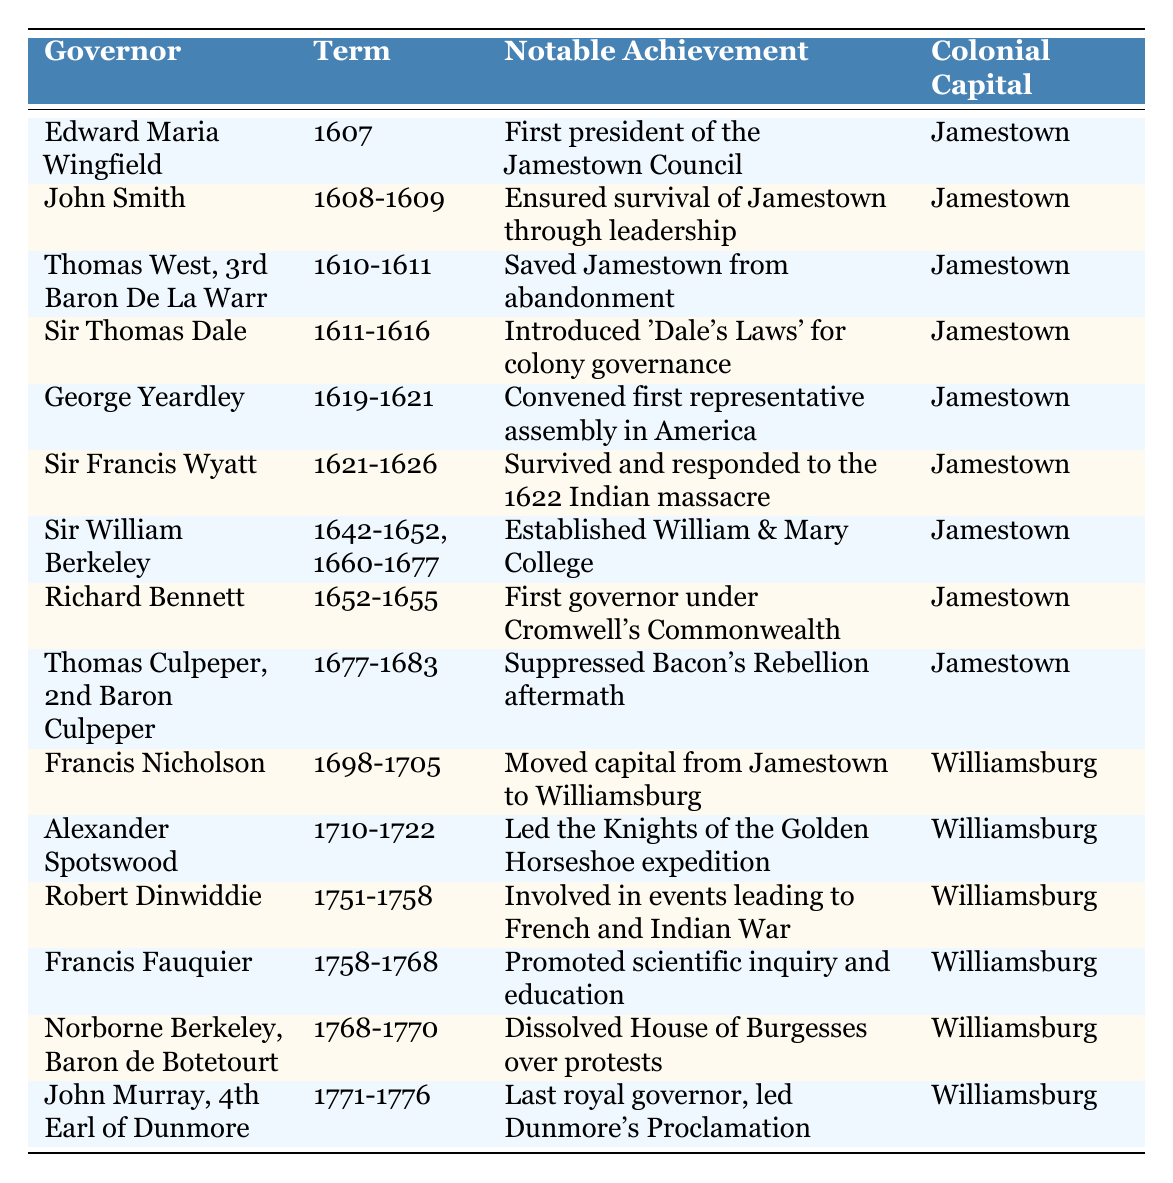What was the term of Sir William Berkeley? The table shows that Sir William Berkeley served two terms: the first from 1642 to 1652 and the second from 1660 to 1677.
Answer: 1642-1652, 1660-1677 Who introduced 'Dale's Laws' for colony governance? According to the table, 'Dale's Laws' for colony governance were introduced by Sir Thomas Dale during his term from 1611 to 1616.
Answer: Sir Thomas Dale Which governor served right before the capital was moved to Williamsburg? The table indicates that Francis Nicholson served from 1698 to 1705, and he is listed directly before the governor who succeeded him, Alexander Spotswood, indicating he was the last governor before the capital moved to Williamsburg.
Answer: Francis Nicholson How many governors served during the 17th century? By reviewing the years of service in the table, the governors Edward Maria Wingfield, John Smith, Thomas West, Sir Thomas Dale, George Yeardley, Sir Francis Wyatt, Sir William Berkeley, Richard Bennett, and Thomas Culpeper were all from the 17th century. Counting them gives a total of 9 governors.
Answer: 9 Did any governors serve in Williamsburg before 1700? By examining the table, it can be seen that Francis Nicholson was the first to serve in Williamsburg starting from 1698, meaning no governors served in Williamsburg before that year.
Answer: No Which governor's notable achievement was promoting scientific inquiry and education? The table reveals that Francis Fauquier, who served from 1758 to 1768, had the notable achievement of promoting scientific inquiry and education.
Answer: Francis Fauquier What is the notable achievement of the last governor before the American Revolution? According to the table, John Murray, the 4th Earl of Dunmore, led Dunmore's Proclamation as his notable achievement, right before the American Revolution.
Answer: Led Dunmore's Proclamation How many years did Sir Francis Wyatt serve as governor? Sir Francis Wyatt served from 1621 to 1626, which is a total of 5 years.
Answer: 5 years Which two governors had their terms interrupted? Reviewing the table, Sir William Berkeley had two non-consecutive terms, serving first from 1642 to 1652 and again from 1660 to 1677, indicating his service was interrupted.
Answer: Sir William Berkeley What can be said about George Yeardley's significance in American history? The table mentions that George Yeardley convened the first representative assembly in America during his term from 1619 to 1621, indicating his significant contribution to democratic governance.
Answer: Key figure in American democracy 